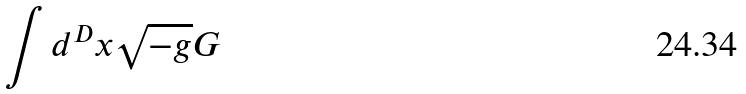Convert formula to latex. <formula><loc_0><loc_0><loc_500><loc_500>\int d ^ { D } x \sqrt { - g } G</formula> 